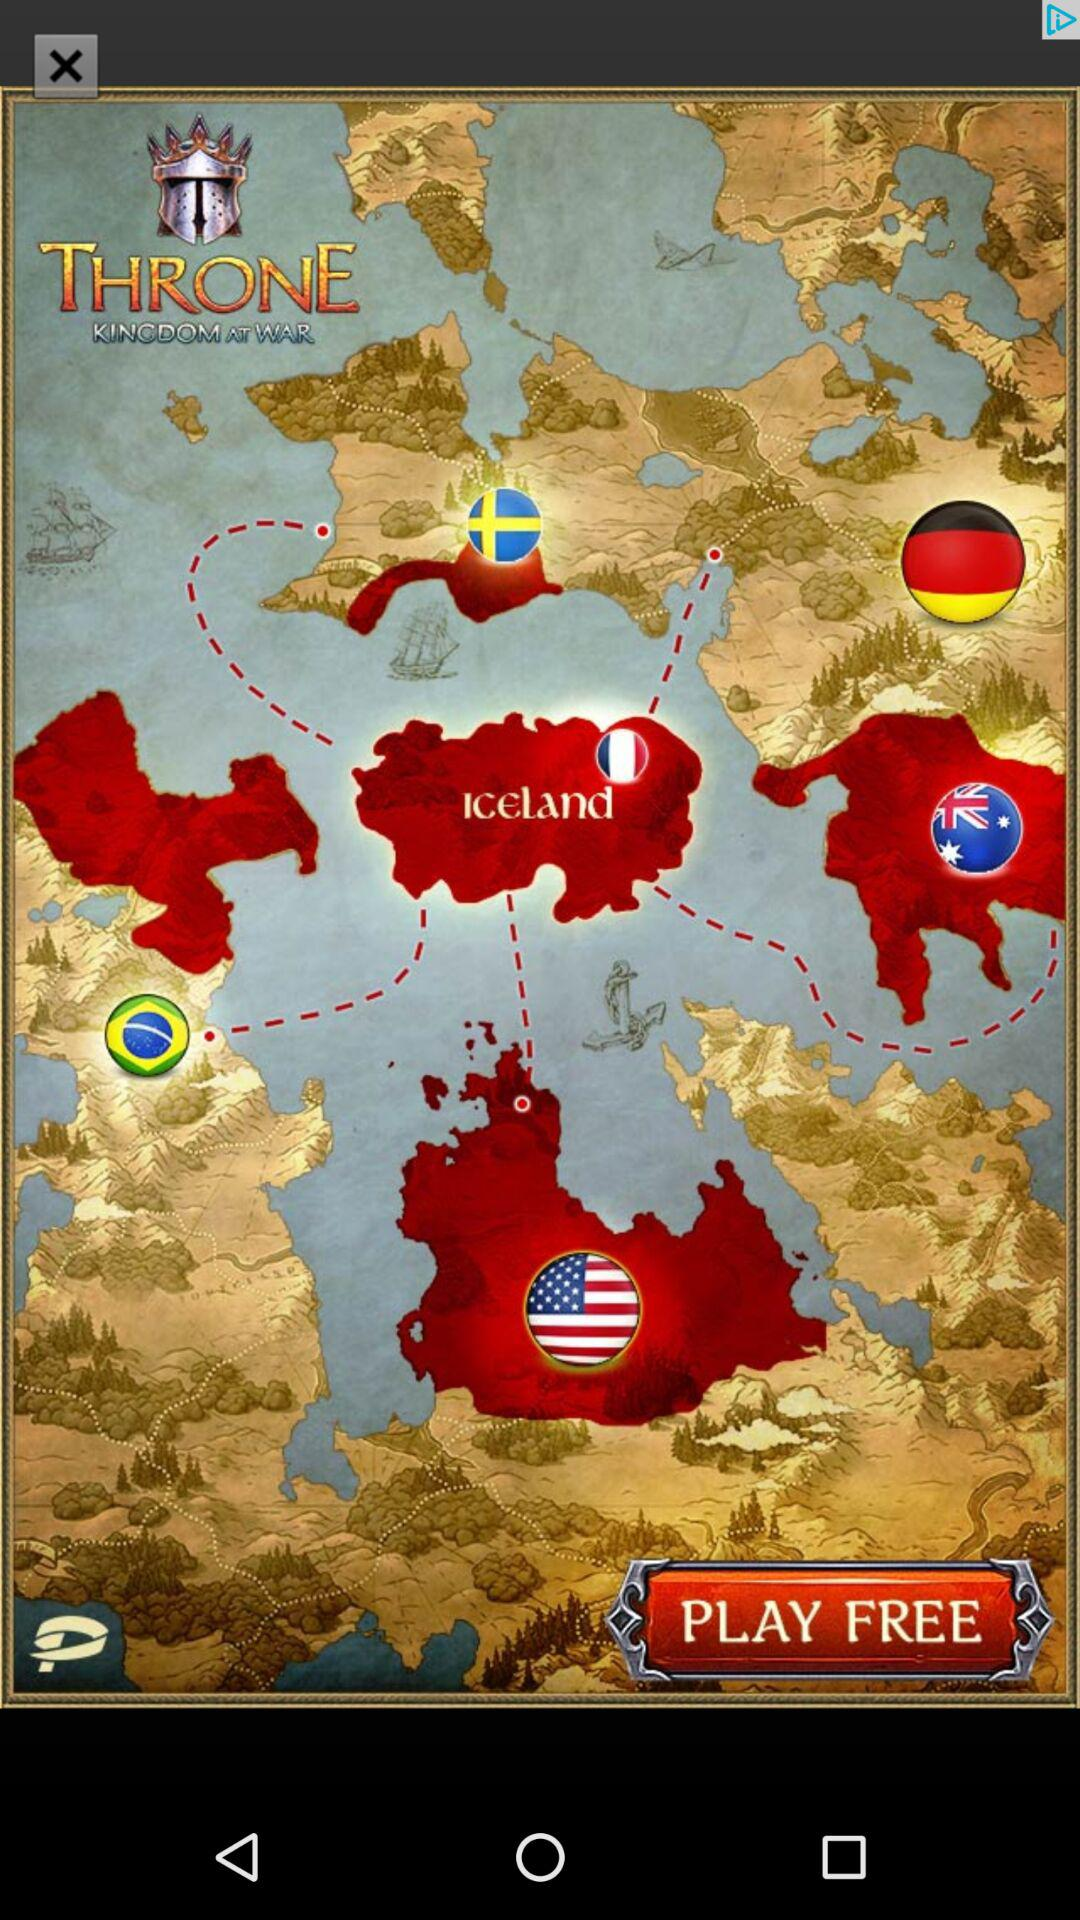How many countries have flags on the map?
Answer the question using a single word or phrase. 6 